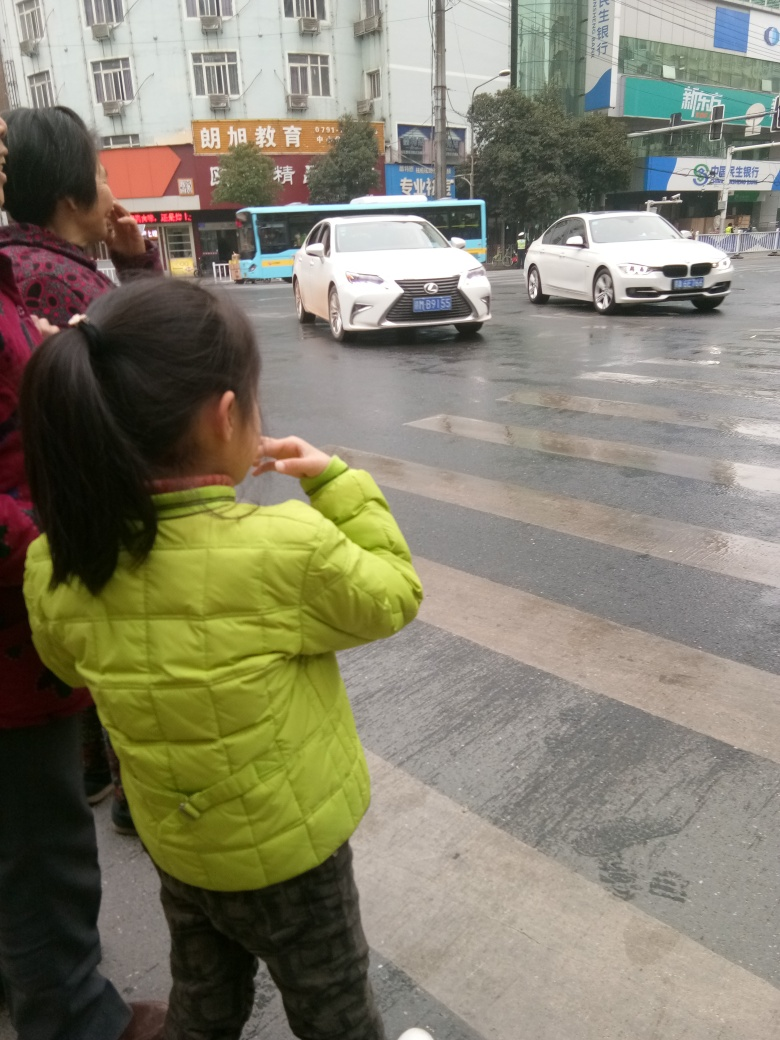What is the weather like in this image, and how might it be affecting the scene? The weather appears to be overcast with potential light drizzle, which can be inferred from the wet pavement and the way people are dressed. This kind of weather might make surfaces slippery and affect visibility for both pedestrians and drivers, thereby necessitating extra caution. What could be improved in the city's infrastructure to enhance pedestrian safety in such weather? Improvements could include better street lighting, non-slip pavement materials, high visibility crosswalks, and perhaps covered pedestrian walkways. Drainage systems could be optimized to prevent puddling, and electronic signs can be installed to alert drivers about crossing pedestrians. 